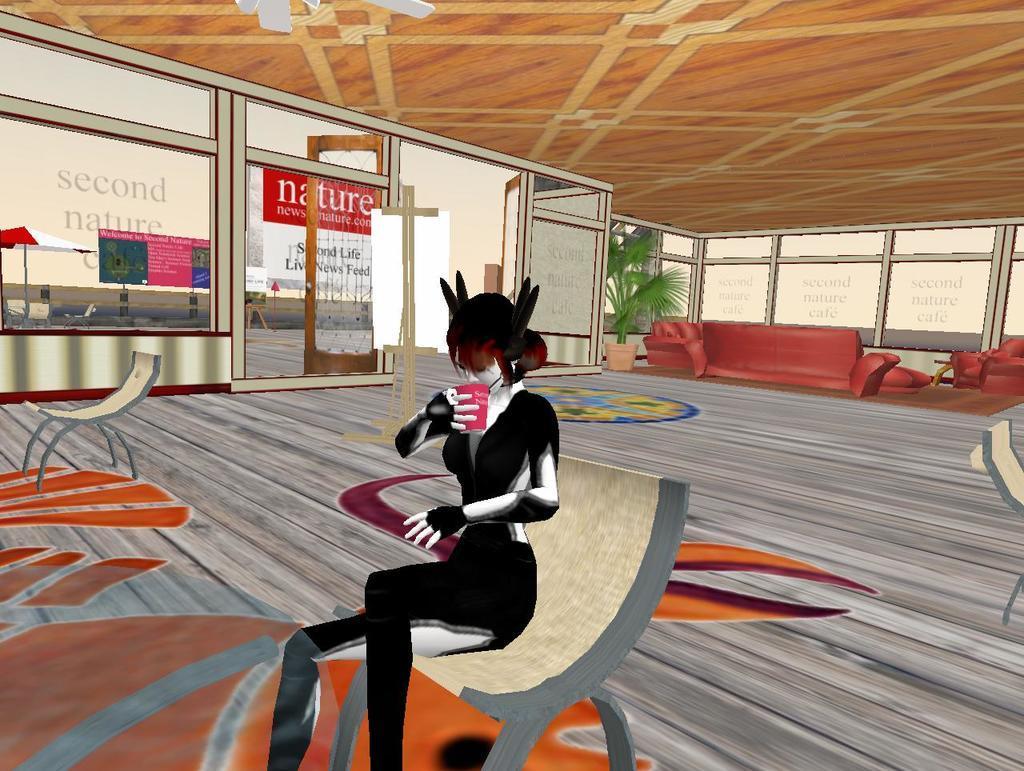Could you give a brief overview of what you see in this image? In this image we can see an animation. In the animation there are the pictures of person sitting on the chair and holding beverage glass, parasols, houseplant, sofa set, floor and carpet. 